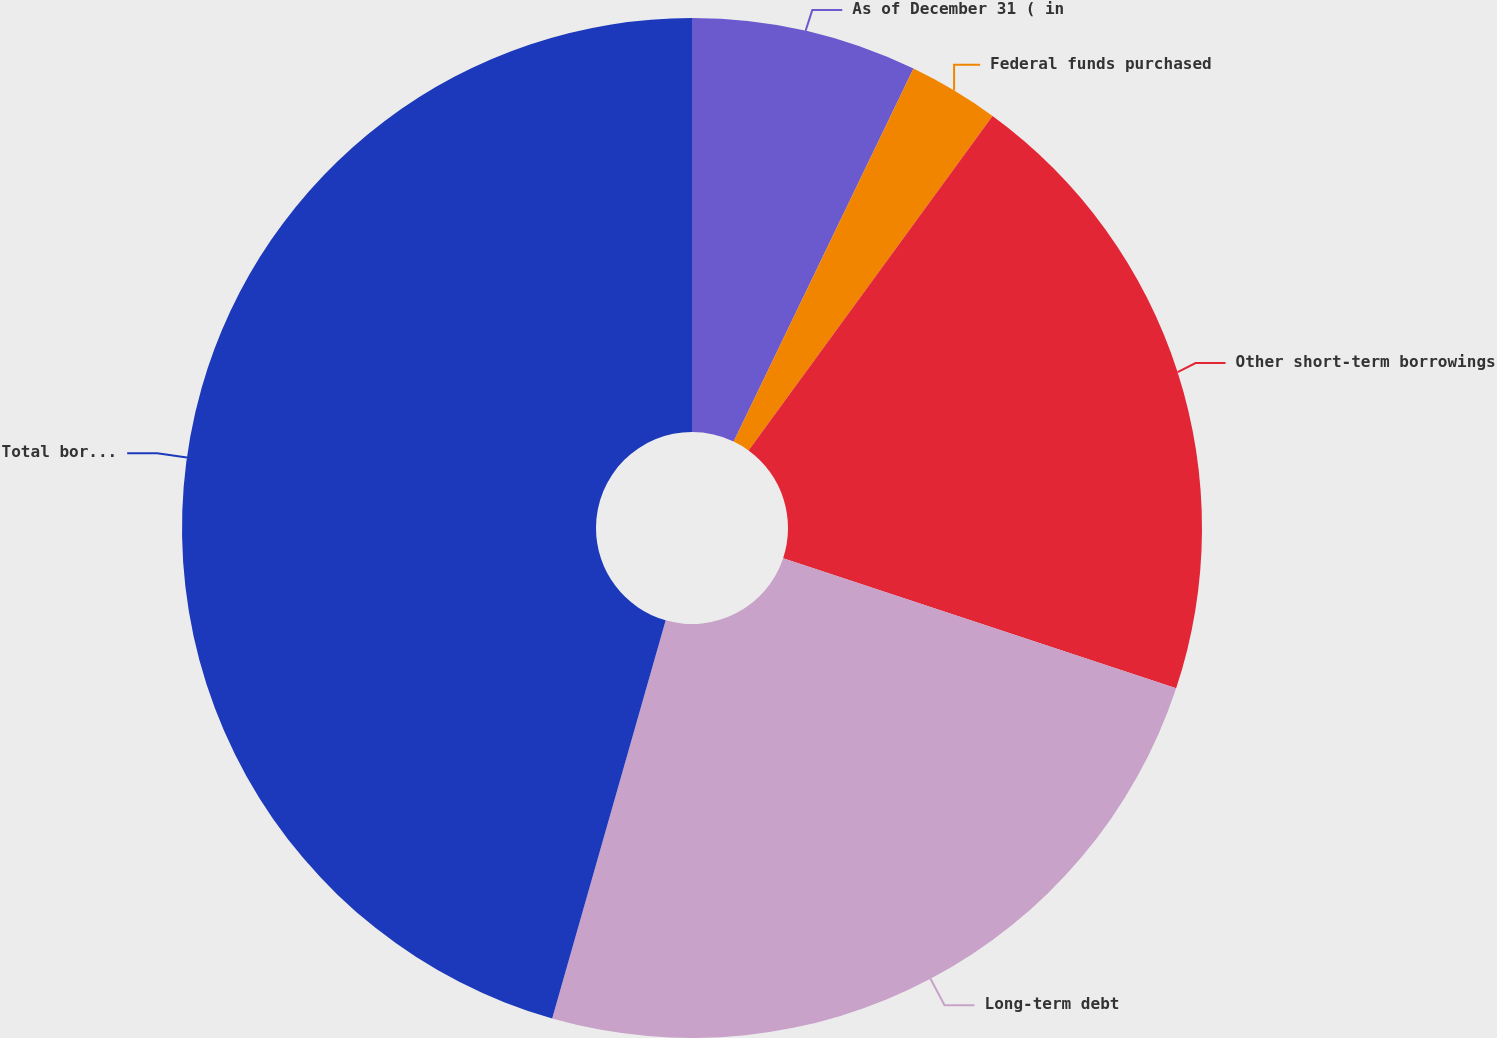Convert chart. <chart><loc_0><loc_0><loc_500><loc_500><pie_chart><fcel>As of December 31 ( in<fcel>Federal funds purchased<fcel>Other short-term borrowings<fcel>Long-term debt<fcel>Total borrowings<nl><fcel>7.15%<fcel>2.88%<fcel>20.06%<fcel>24.33%<fcel>45.58%<nl></chart> 